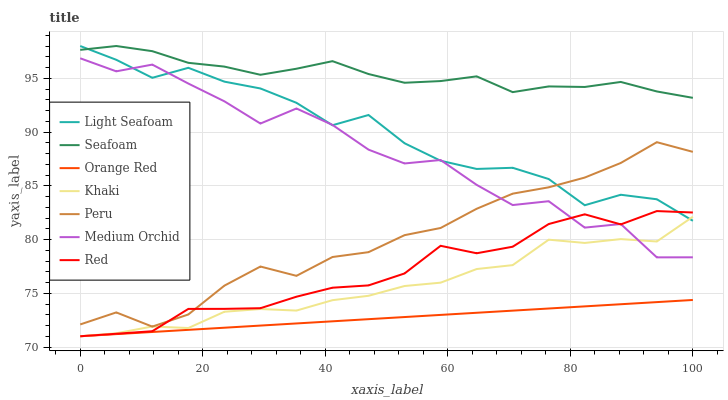Does Medium Orchid have the minimum area under the curve?
Answer yes or no. No. Does Medium Orchid have the maximum area under the curve?
Answer yes or no. No. Is Seafoam the smoothest?
Answer yes or no. No. Is Seafoam the roughest?
Answer yes or no. No. Does Medium Orchid have the lowest value?
Answer yes or no. No. Does Medium Orchid have the highest value?
Answer yes or no. No. Is Medium Orchid less than Seafoam?
Answer yes or no. Yes. Is Seafoam greater than Red?
Answer yes or no. Yes. Does Medium Orchid intersect Seafoam?
Answer yes or no. No. 